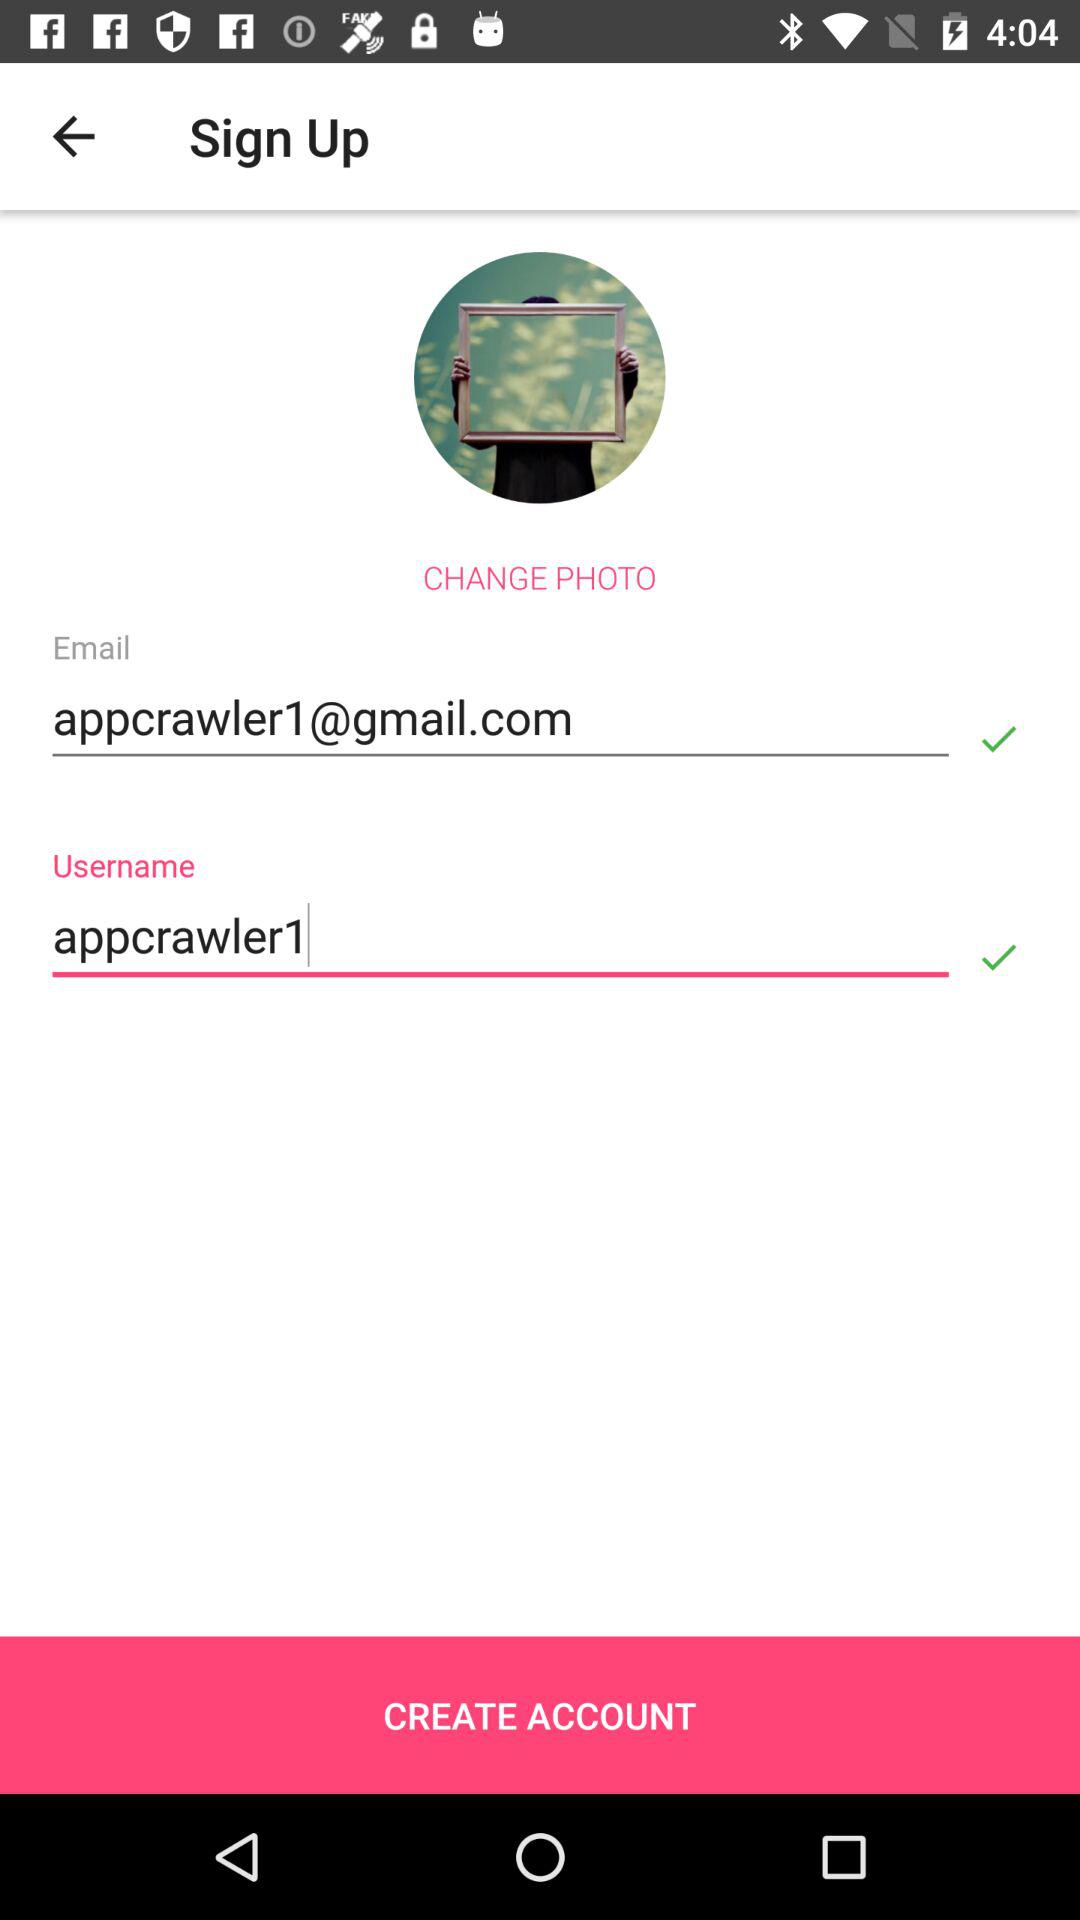What's the username? The username is appcrawler1. 